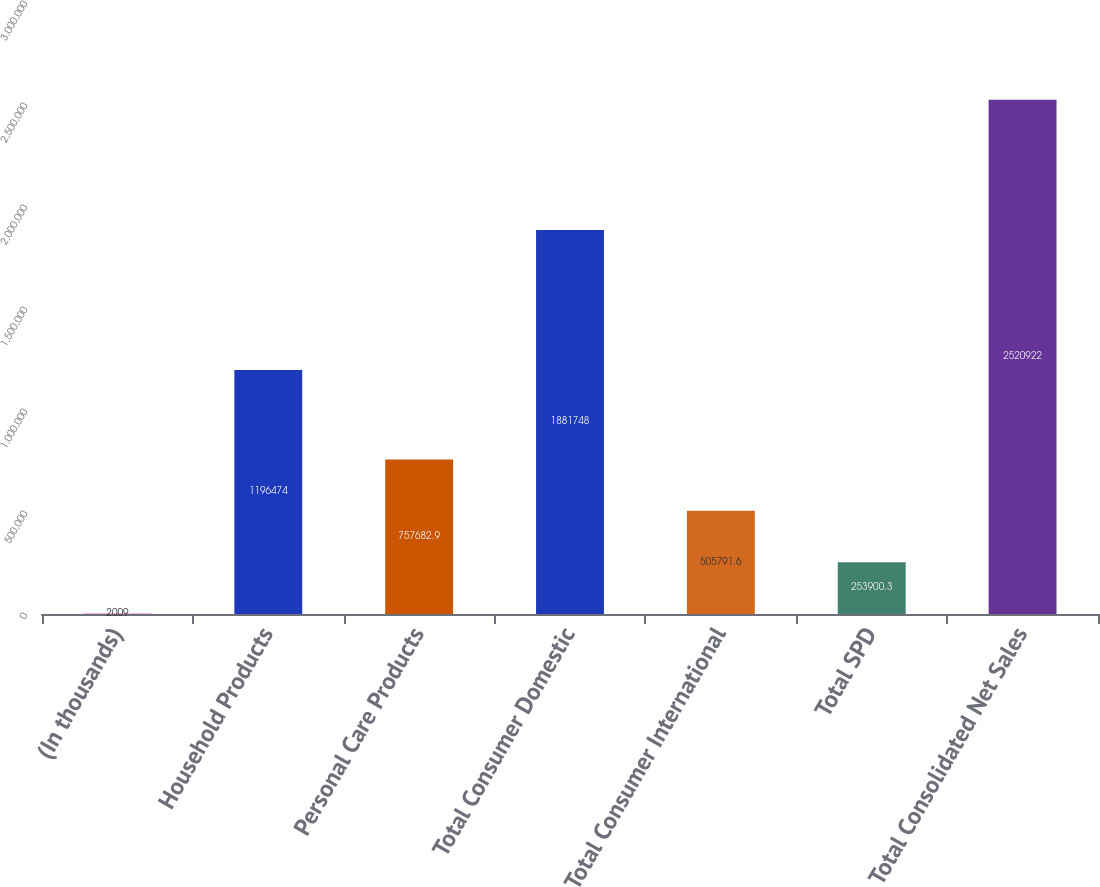<chart> <loc_0><loc_0><loc_500><loc_500><bar_chart><fcel>(In thousands)<fcel>Household Products<fcel>Personal Care Products<fcel>Total Consumer Domestic<fcel>Total Consumer International<fcel>Total SPD<fcel>Total Consolidated Net Sales<nl><fcel>2009<fcel>1.19647e+06<fcel>757683<fcel>1.88175e+06<fcel>505792<fcel>253900<fcel>2.52092e+06<nl></chart> 